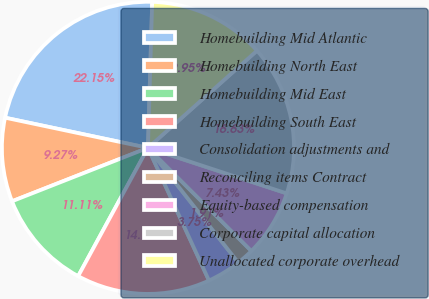<chart> <loc_0><loc_0><loc_500><loc_500><pie_chart><fcel>Homebuilding Mid Atlantic<fcel>Homebuilding North East<fcel>Homebuilding Mid East<fcel>Homebuilding South East<fcel>Consolidation adjustments and<fcel>Reconciling items Contract<fcel>Equity-based compensation<fcel>Corporate capital allocation<fcel>Unallocated corporate overhead<nl><fcel>22.15%<fcel>9.27%<fcel>11.11%<fcel>14.79%<fcel>3.75%<fcel>1.91%<fcel>7.43%<fcel>16.63%<fcel>12.95%<nl></chart> 